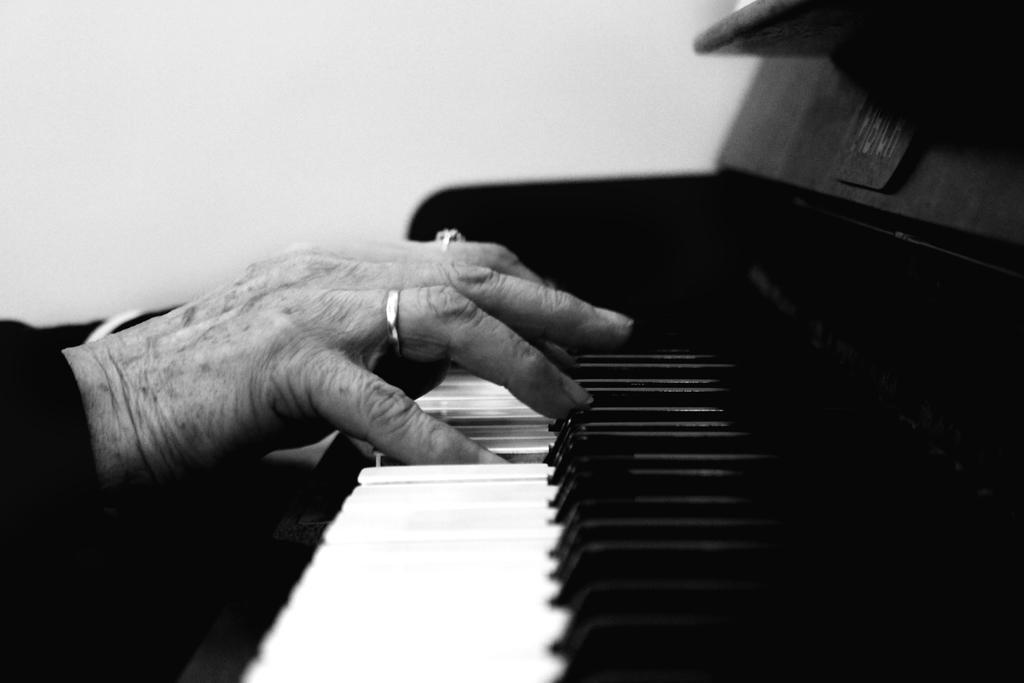Could you give a brief overview of what you see in this image? As we can see in the image there is a white color wall, and a person playing black and white color musical keyboard. 